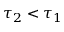Convert formula to latex. <formula><loc_0><loc_0><loc_500><loc_500>\tau _ { 2 } < \tau _ { 1 }</formula> 